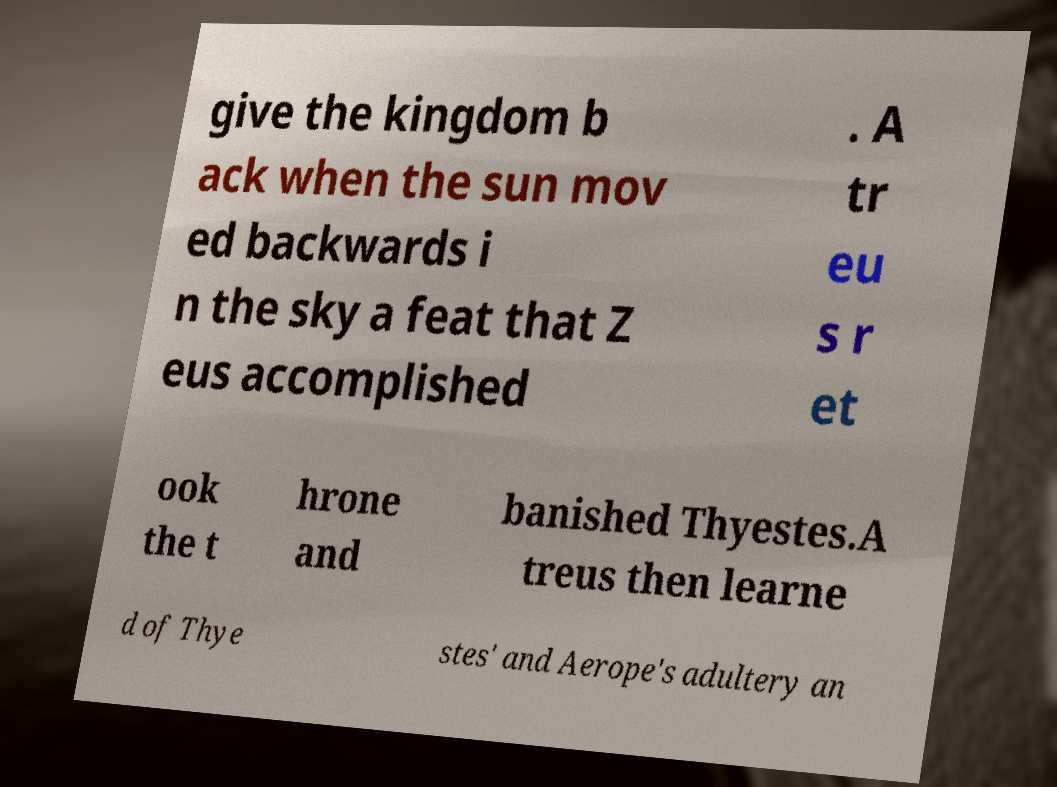Could you extract and type out the text from this image? give the kingdom b ack when the sun mov ed backwards i n the sky a feat that Z eus accomplished . A tr eu s r et ook the t hrone and banished Thyestes.A treus then learne d of Thye stes' and Aerope's adultery an 